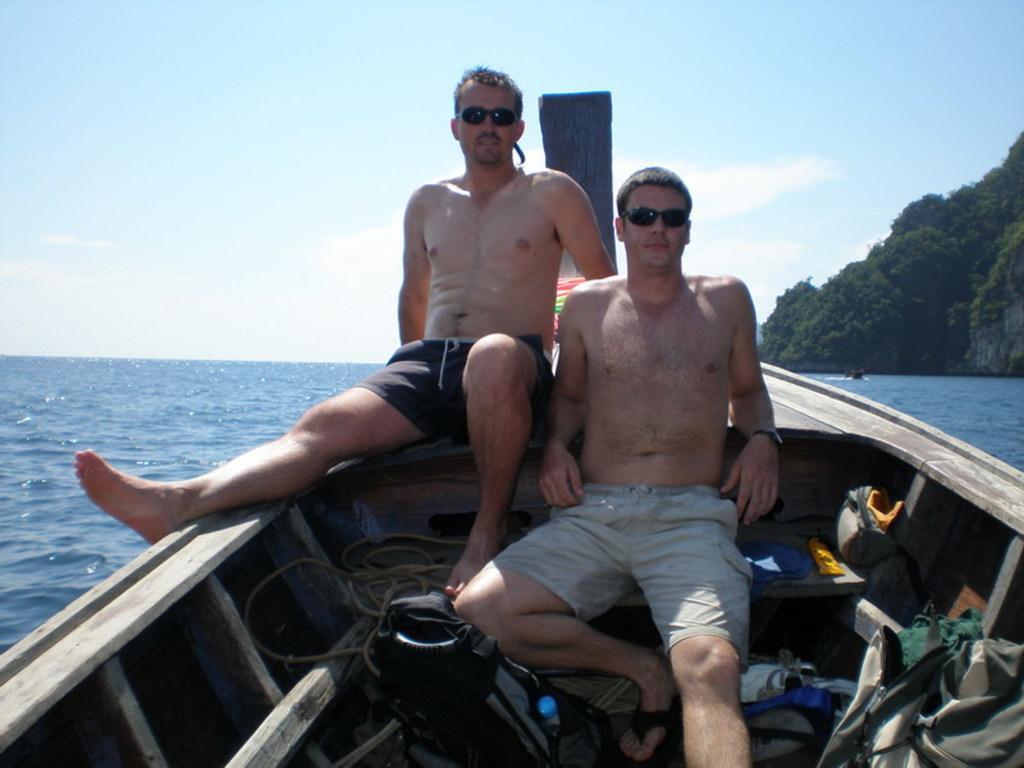Please provide a concise description of this image. In this picture there is a boat in the center of the image, on the water and there are two men in it, there is water in the center of the image and there is a mountain on the right side of the image. 